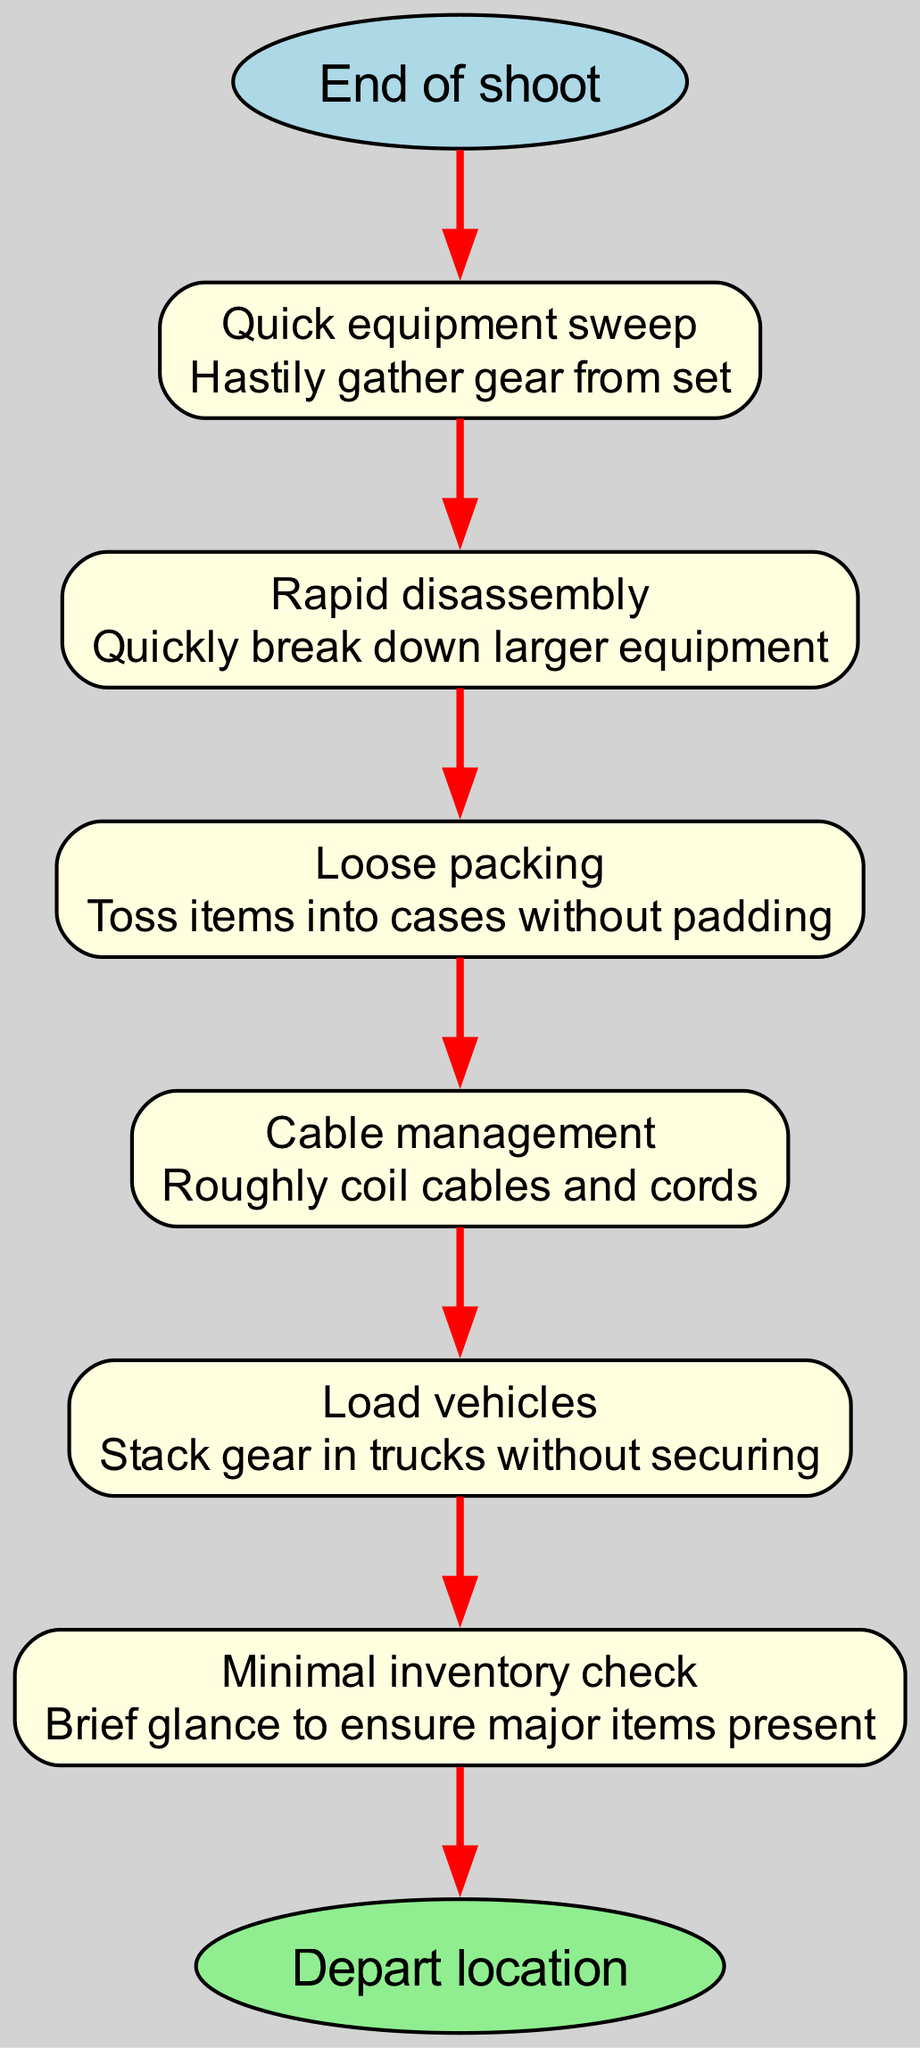What is the first step after the end of the shoot? The diagram focuses on a sequence of actions that begin right after the end of the shoot. The first step listed is "Quick equipment sweep".
Answer: Quick equipment sweep How many steps are in the procedure? By counting the individual actions outlined in the diagram, we can see there are six distinct steps leading to the conclusion.
Answer: 6 What is the last node before departing the location? The final step in the flow chart leads to the end node, which is specifically labeled as "Depart location", marking the conclusion of the breakdown procedure.
Answer: Depart location Which step involves organizing cables? By reviewing the steps, "Cable management" is identified as the action that specifically involves dealing with cables and cords.
Answer: Cable management What is the action taken during "Loose packing"? The description notes that this step involves tossing items into cases without the use of any padding, emphasizing a less careful approach to packing.
Answer: Toss items into cases without padding Which step comes after "Rapid disassembly"? Following the flow direction from "Rapid disassembly", the next step in sequence is "Loose packing". This illustrates the continuation of the process after disassembling equipment.
Answer: Loose packing What is described in "Minimal inventory check"? This step includes taking a brief glance to ensure that major items are present, indicating a quick yet insufficient verification of the remaining equipment.
Answer: Brief glance to ensure major items present How are the cables handled in the procedure? The step labeled "Cable management" indicates that cables and cords are handled by being coiled roughly, suggesting that the process is not thorough or meticulous.
Answer: Roughly coil cables and cords 